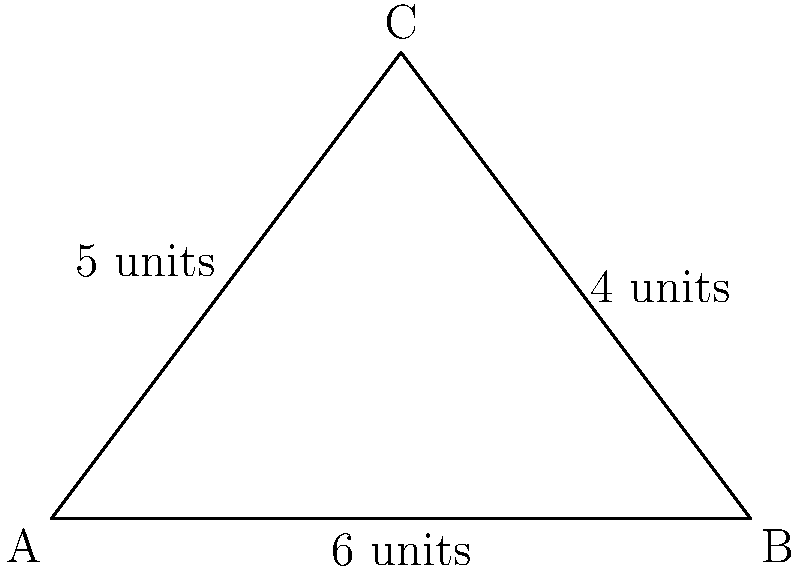As you deliver mail along the streets of Auden Padariya, you notice a triangular park bounded by three streets. The park has the following dimensions: one side is 6 units long, another side is 4 units long, and the third side is 5 units long. What is the area of this triangular park? To find the area of the triangular park, we can use Heron's formula. Let's follow these steps:

1) Heron's formula states that the area $A$ of a triangle with sides $a$, $b$, and $c$ is:

   $A = \sqrt{s(s-a)(s-b)(s-c)}$

   where $s$ is the semi-perimeter: $s = \frac{a+b+c}{2}$

2) In our case, $a = 6$, $b = 4$, and $c = 5$.

3) Let's calculate the semi-perimeter $s$:
   
   $s = \frac{6+4+5}{2} = \frac{15}{2} = 7.5$

4) Now, let's substitute these values into Heron's formula:

   $A = \sqrt{7.5(7.5-6)(7.5-4)(7.5-5)}$

5) Simplify inside the parentheses:

   $A = \sqrt{7.5 \cdot 1.5 \cdot 3.5 \cdot 2.5}$

6) Multiply the numbers inside the square root:

   $A = \sqrt{98.4375}$

7) Calculate the square root:

   $A \approx 9.92$ square units

Therefore, the area of the triangular park is approximately 9.92 square units.
Answer: 9.92 square units 